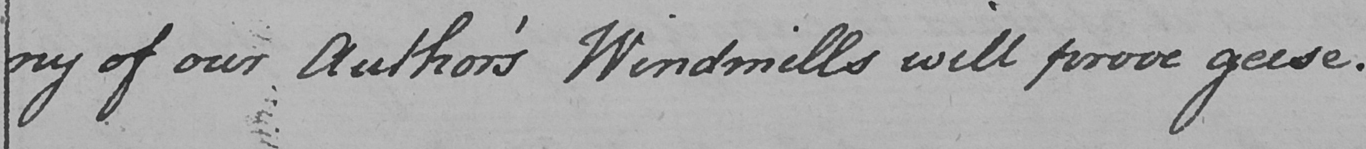What is written in this line of handwriting? ny of our Author ' s Windmills will prove geese . 